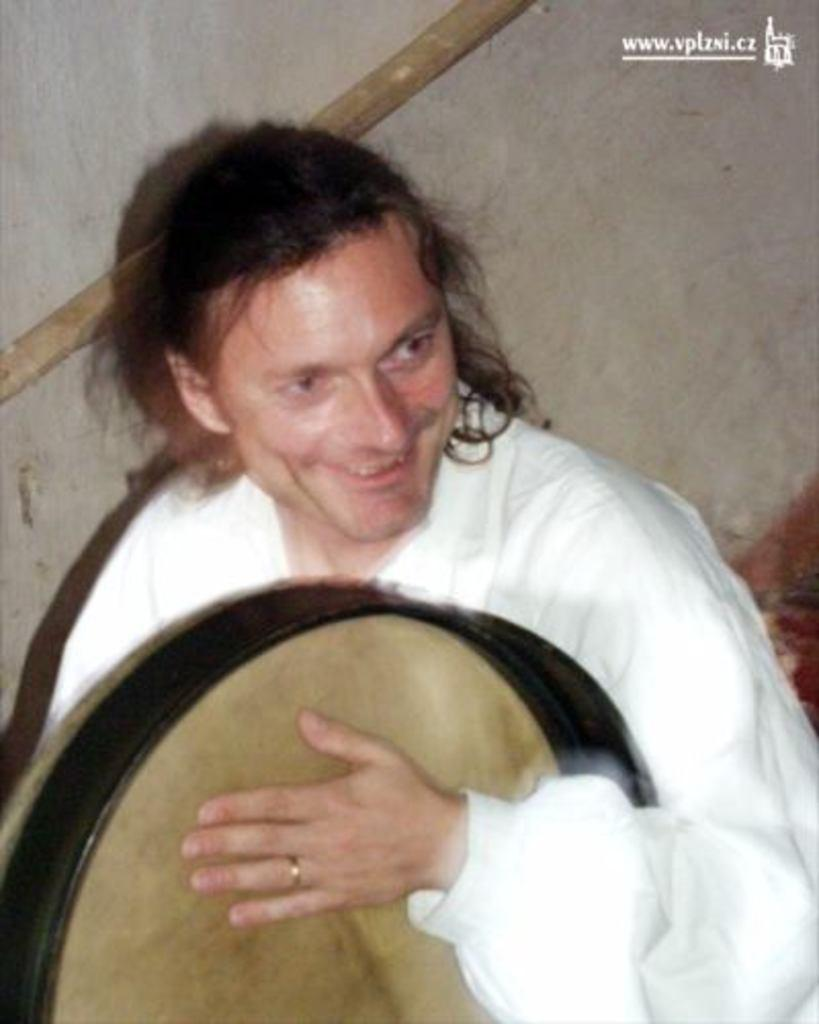What is the man in the image holding? The man is holding a drum. What is the man's facial expression in the image? The man is smiling. What is the man wearing in the image? The man is wearing a white-colored dress. Can you see a plane flying in the background of the image? There is no plane visible in the background of the image. Is the man holding a balloon in the image? No, the man is holding a drum, not a balloon. 